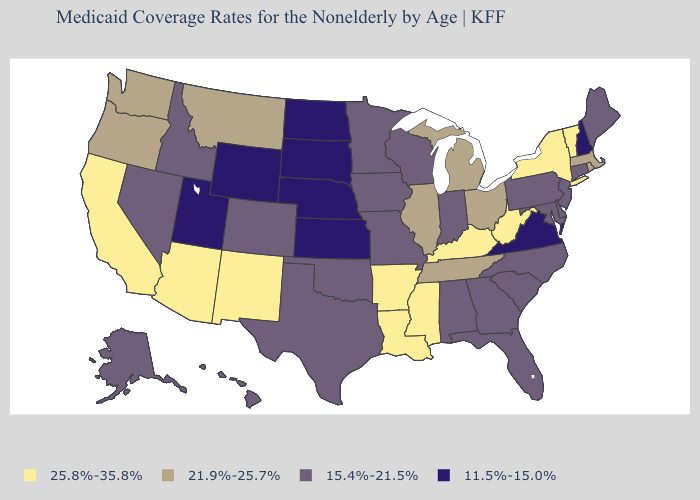Name the states that have a value in the range 21.9%-25.7%?
Quick response, please. Illinois, Massachusetts, Michigan, Montana, Ohio, Oregon, Rhode Island, Tennessee, Washington. What is the value of Wisconsin?
Give a very brief answer. 15.4%-21.5%. What is the value of Massachusetts?
Give a very brief answer. 21.9%-25.7%. Which states have the lowest value in the South?
Keep it brief. Virginia. What is the lowest value in the USA?
Be succinct. 11.5%-15.0%. What is the lowest value in the USA?
Keep it brief. 11.5%-15.0%. Does Hawaii have the lowest value in the USA?
Keep it brief. No. How many symbols are there in the legend?
Answer briefly. 4. What is the value of Pennsylvania?
Write a very short answer. 15.4%-21.5%. What is the lowest value in states that border Arizona?
Concise answer only. 11.5%-15.0%. Name the states that have a value in the range 15.4%-21.5%?
Keep it brief. Alabama, Alaska, Colorado, Connecticut, Delaware, Florida, Georgia, Hawaii, Idaho, Indiana, Iowa, Maine, Maryland, Minnesota, Missouri, Nevada, New Jersey, North Carolina, Oklahoma, Pennsylvania, South Carolina, Texas, Wisconsin. What is the value of Colorado?
Quick response, please. 15.4%-21.5%. Name the states that have a value in the range 11.5%-15.0%?
Be succinct. Kansas, Nebraska, New Hampshire, North Dakota, South Dakota, Utah, Virginia, Wyoming. What is the value of Kansas?
Write a very short answer. 11.5%-15.0%. What is the highest value in states that border Pennsylvania?
Answer briefly. 25.8%-35.8%. 